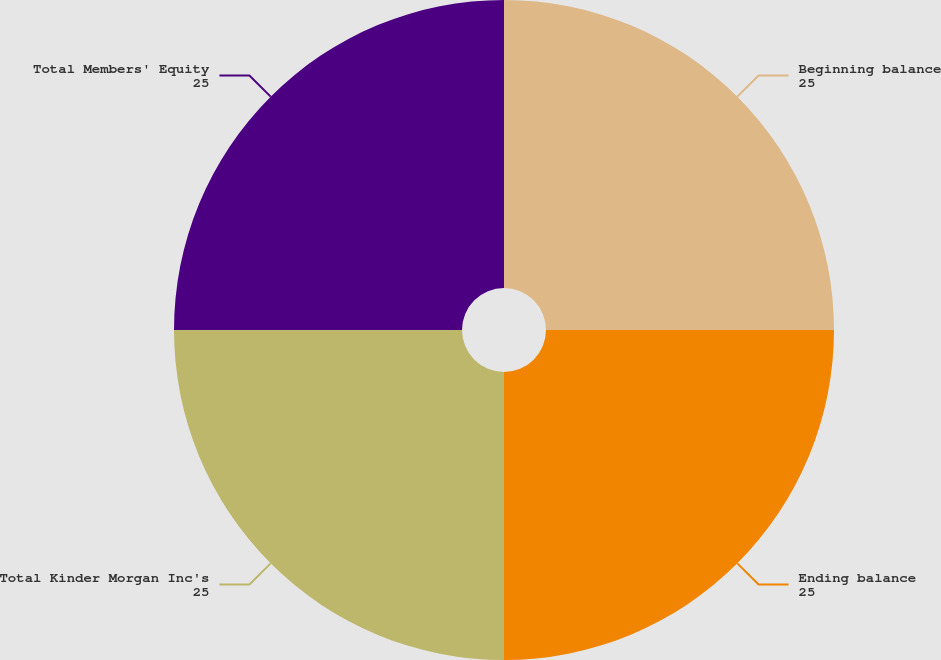Convert chart. <chart><loc_0><loc_0><loc_500><loc_500><pie_chart><fcel>Beginning balance<fcel>Ending balance<fcel>Total Kinder Morgan Inc's<fcel>Total Members' Equity<nl><fcel>25.0%<fcel>25.0%<fcel>25.0%<fcel>25.0%<nl></chart> 